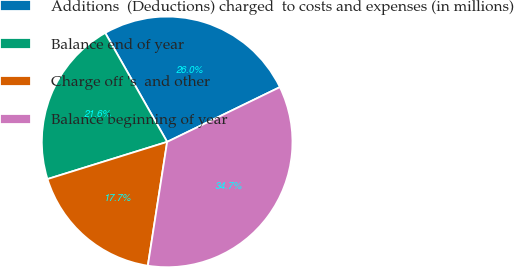Convert chart to OTSL. <chart><loc_0><loc_0><loc_500><loc_500><pie_chart><fcel>Additions  (Deductions) charged  to costs and expenses (in millions)<fcel>Balance end of year<fcel>Charge off 's  and other<fcel>Balance beginning of year<nl><fcel>26.03%<fcel>21.57%<fcel>17.74%<fcel>34.66%<nl></chart> 